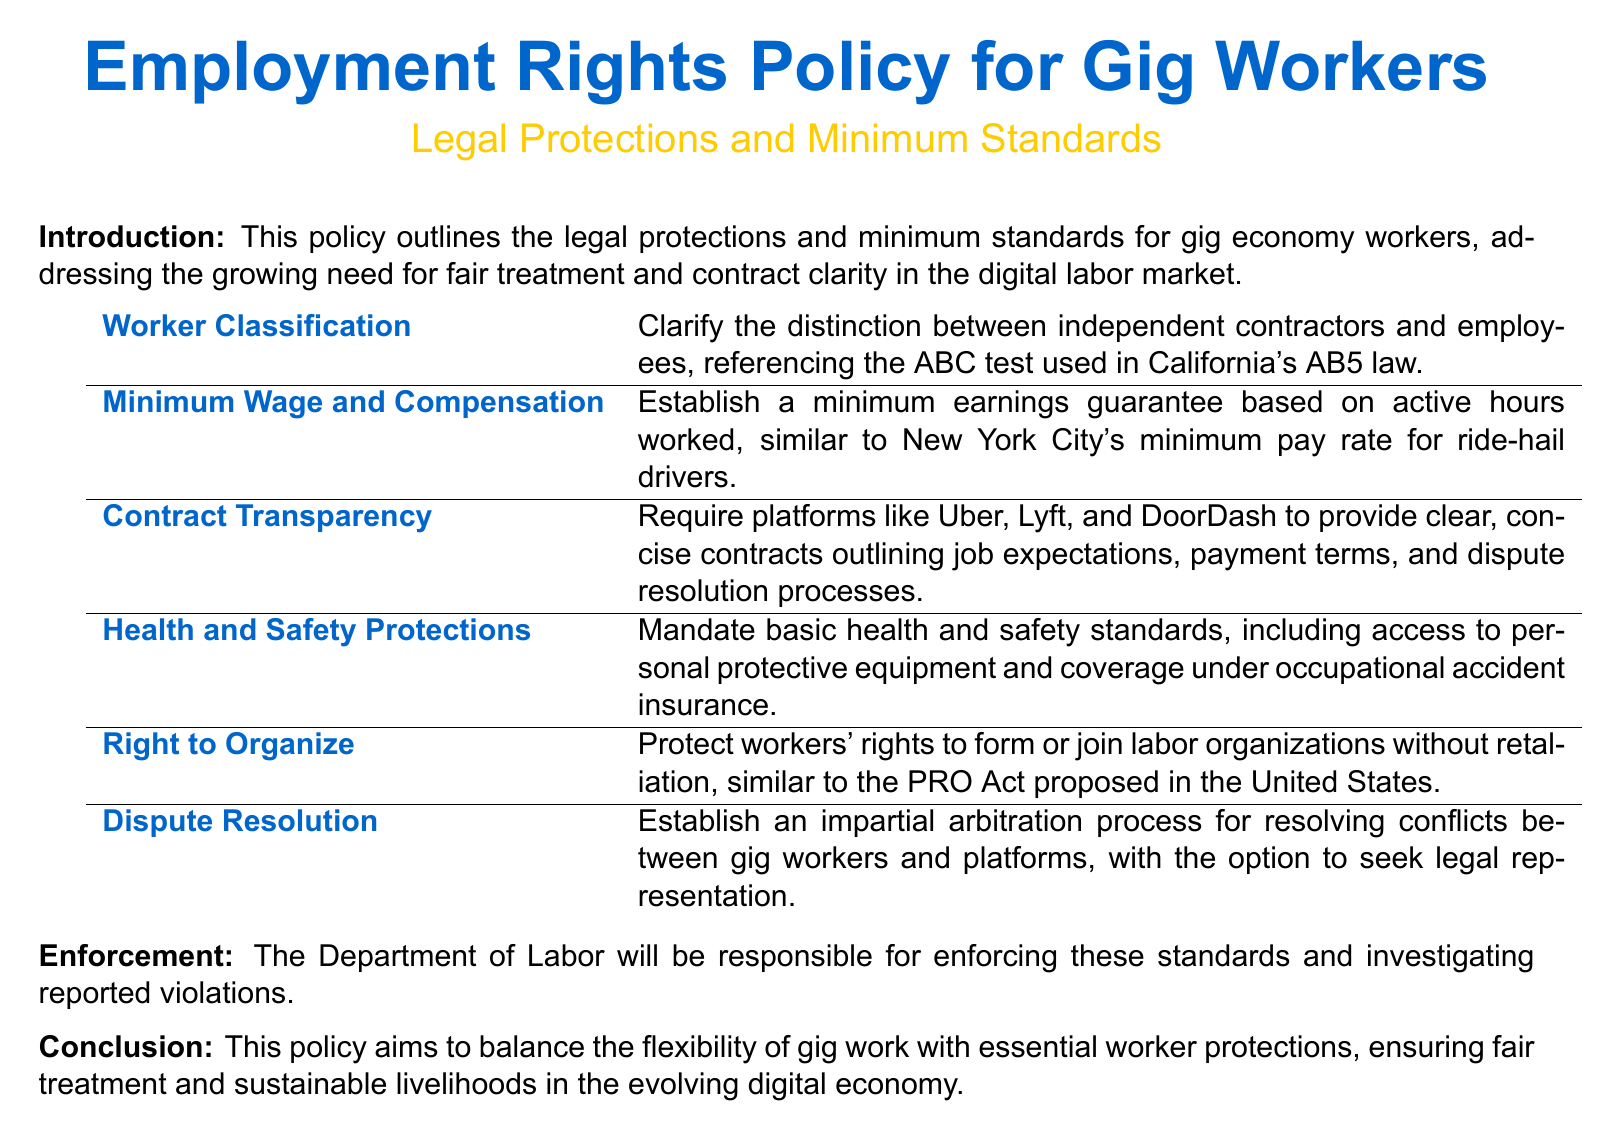What is the title of the policy document? The title of the document is stated at the beginning and highlights the main subject it addresses regarding gig workers.
Answer: Employment Rights Policy for Gig Workers What is the purpose of this policy? The purpose is outlined in the introduction, focusing on the need for fair treatment and contract clarity in the gig economy.
Answer: Fair treatment and contract clarity What test is referenced for worker classification? The document mentions a specific test used to distinguish between independent contractors and employees, particularly in California.
Answer: ABC test What minimum wage standard is mentioned? The document points to a city's specific approach to establishing a minimum pay standard for gig workers.
Answer: New York City's minimum pay rate What rights does the policy protect regarding organizing? The policy emphasizes the right gig workers have in relation to labor organizations and protections from retaliation.
Answer: Right to organize Which department is responsible for enforcement? The document specifies a governmental body tasked with ensuring compliance with the outlined standards.
Answer: Department of Labor What option is provided for dispute resolution? The policy recommends a specific process for resolving conflicts between gig workers and platforms that includes a provision for legal assistance.
Answer: Impartial arbitration process What does the policy mandate regarding health and safety? The document highlights necessary measures to ensure safe working conditions and access to specific items needed for workers' safety.
Answer: Basic health and safety standards What is emphasized in the conclusion? The conclusion reflects on the balance the policy aims to achieve for workers in the context of the evolving labor market.
Answer: Flexibility and essential worker protections 